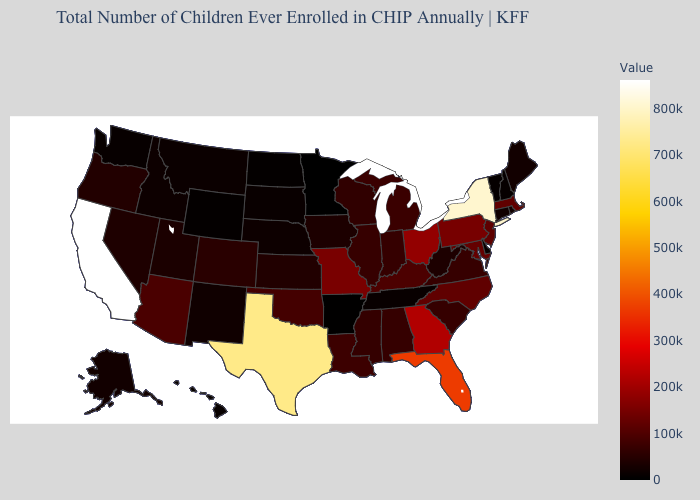Does North Dakota have the highest value in the MidWest?
Give a very brief answer. No. Among the states that border Tennessee , does Arkansas have the lowest value?
Be succinct. Yes. Does Connecticut have the lowest value in the Northeast?
Keep it brief. No. Does West Virginia have the highest value in the USA?
Quick response, please. No. 